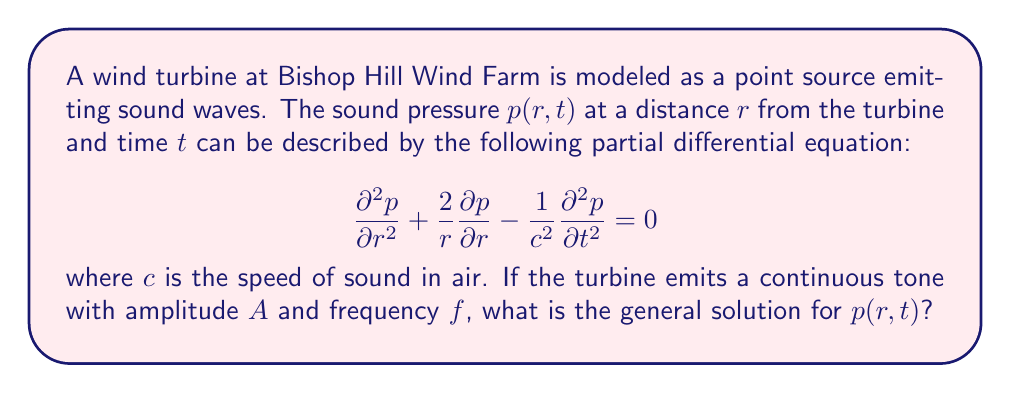Show me your answer to this math problem. To solve this problem, we'll follow these steps:

1) The given equation is the spherical wave equation in 3D space. For a continuous tone, we expect a harmonic solution of the form:

   $$p(r,t) = \frac{1}{r}R(r)e^{i\omega t}$$

   where $\omega = 2\pi f$ is the angular frequency.

2) Substituting this into the original equation:

   $$\frac{d^2R}{dr^2} + \left(\frac{\omega^2}{c^2}\right)R = 0$$

3) This is a standard differential equation with the general solution:

   $$R(r) = C_1e^{ikr} + C_2e^{-ikr}$$

   where $k = \frac{\omega}{c} = \frac{2\pi f}{c}$ is the wave number.

4) However, for outgoing waves from a point source, we only consider the $e^{ikr}$ term. The $e^{-ikr}$ term would represent incoming waves.

5) Therefore, the general solution is:

   $$p(r,t) = \frac{C}{r}e^{i(kr-\omega t)}$$

6) To match the given amplitude $A$, we set $C = A$. 

7) The real part of this complex solution gives the physical sound pressure:

   $$p(r,t) = \frac{A}{r}\cos(kr-\omega t)$$
Answer: The general solution for the sound pressure $p(r,t)$ is:

$$p(r,t) = \frac{A}{r}\cos\left(\frac{2\pi fr}{c} - 2\pi ft\right)$$

where $A$ is the amplitude, $f$ is the frequency, $r$ is the distance from the turbine, $t$ is time, and $c$ is the speed of sound in air. 